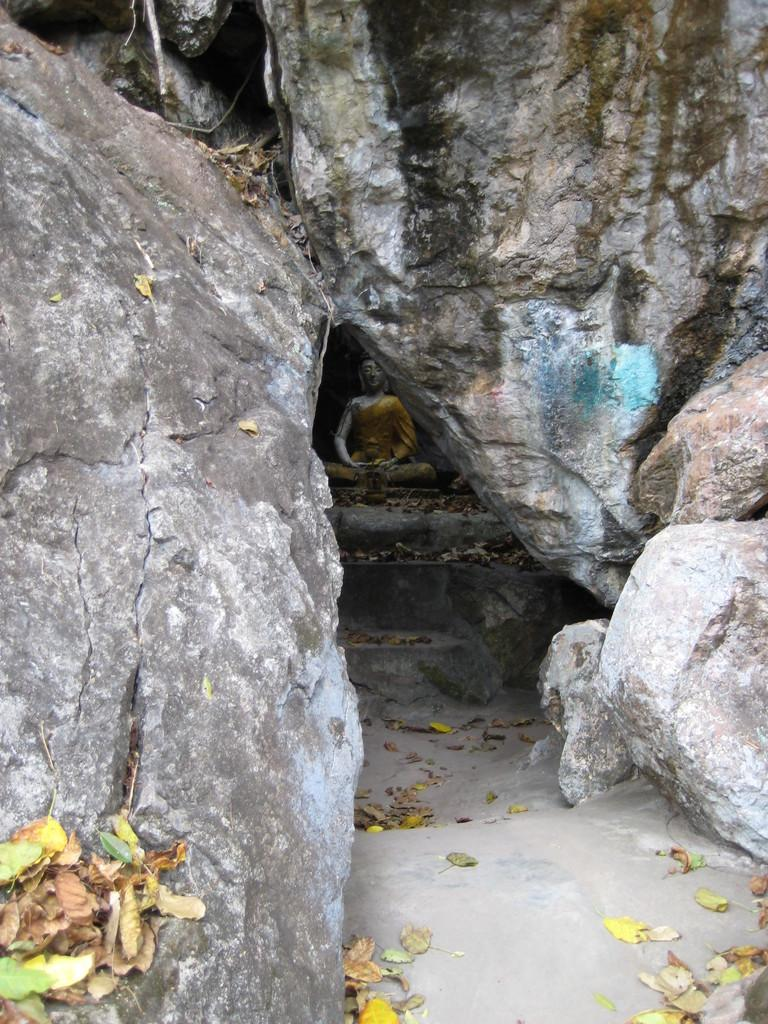What type of natural elements can be seen in the image? There are rocks and dry leaves in the image. What man-made structures are present in the image? There is a walkway and stairs visible in the image. What can be seen in the background of the image? There is a statue in the background of the image. What type of vessel is being used to collect blood from the rocks in the image? There is no vessel or blood present in the image; it features rocks, dry leaves, a walkway, stairs, and a statue in the background. 